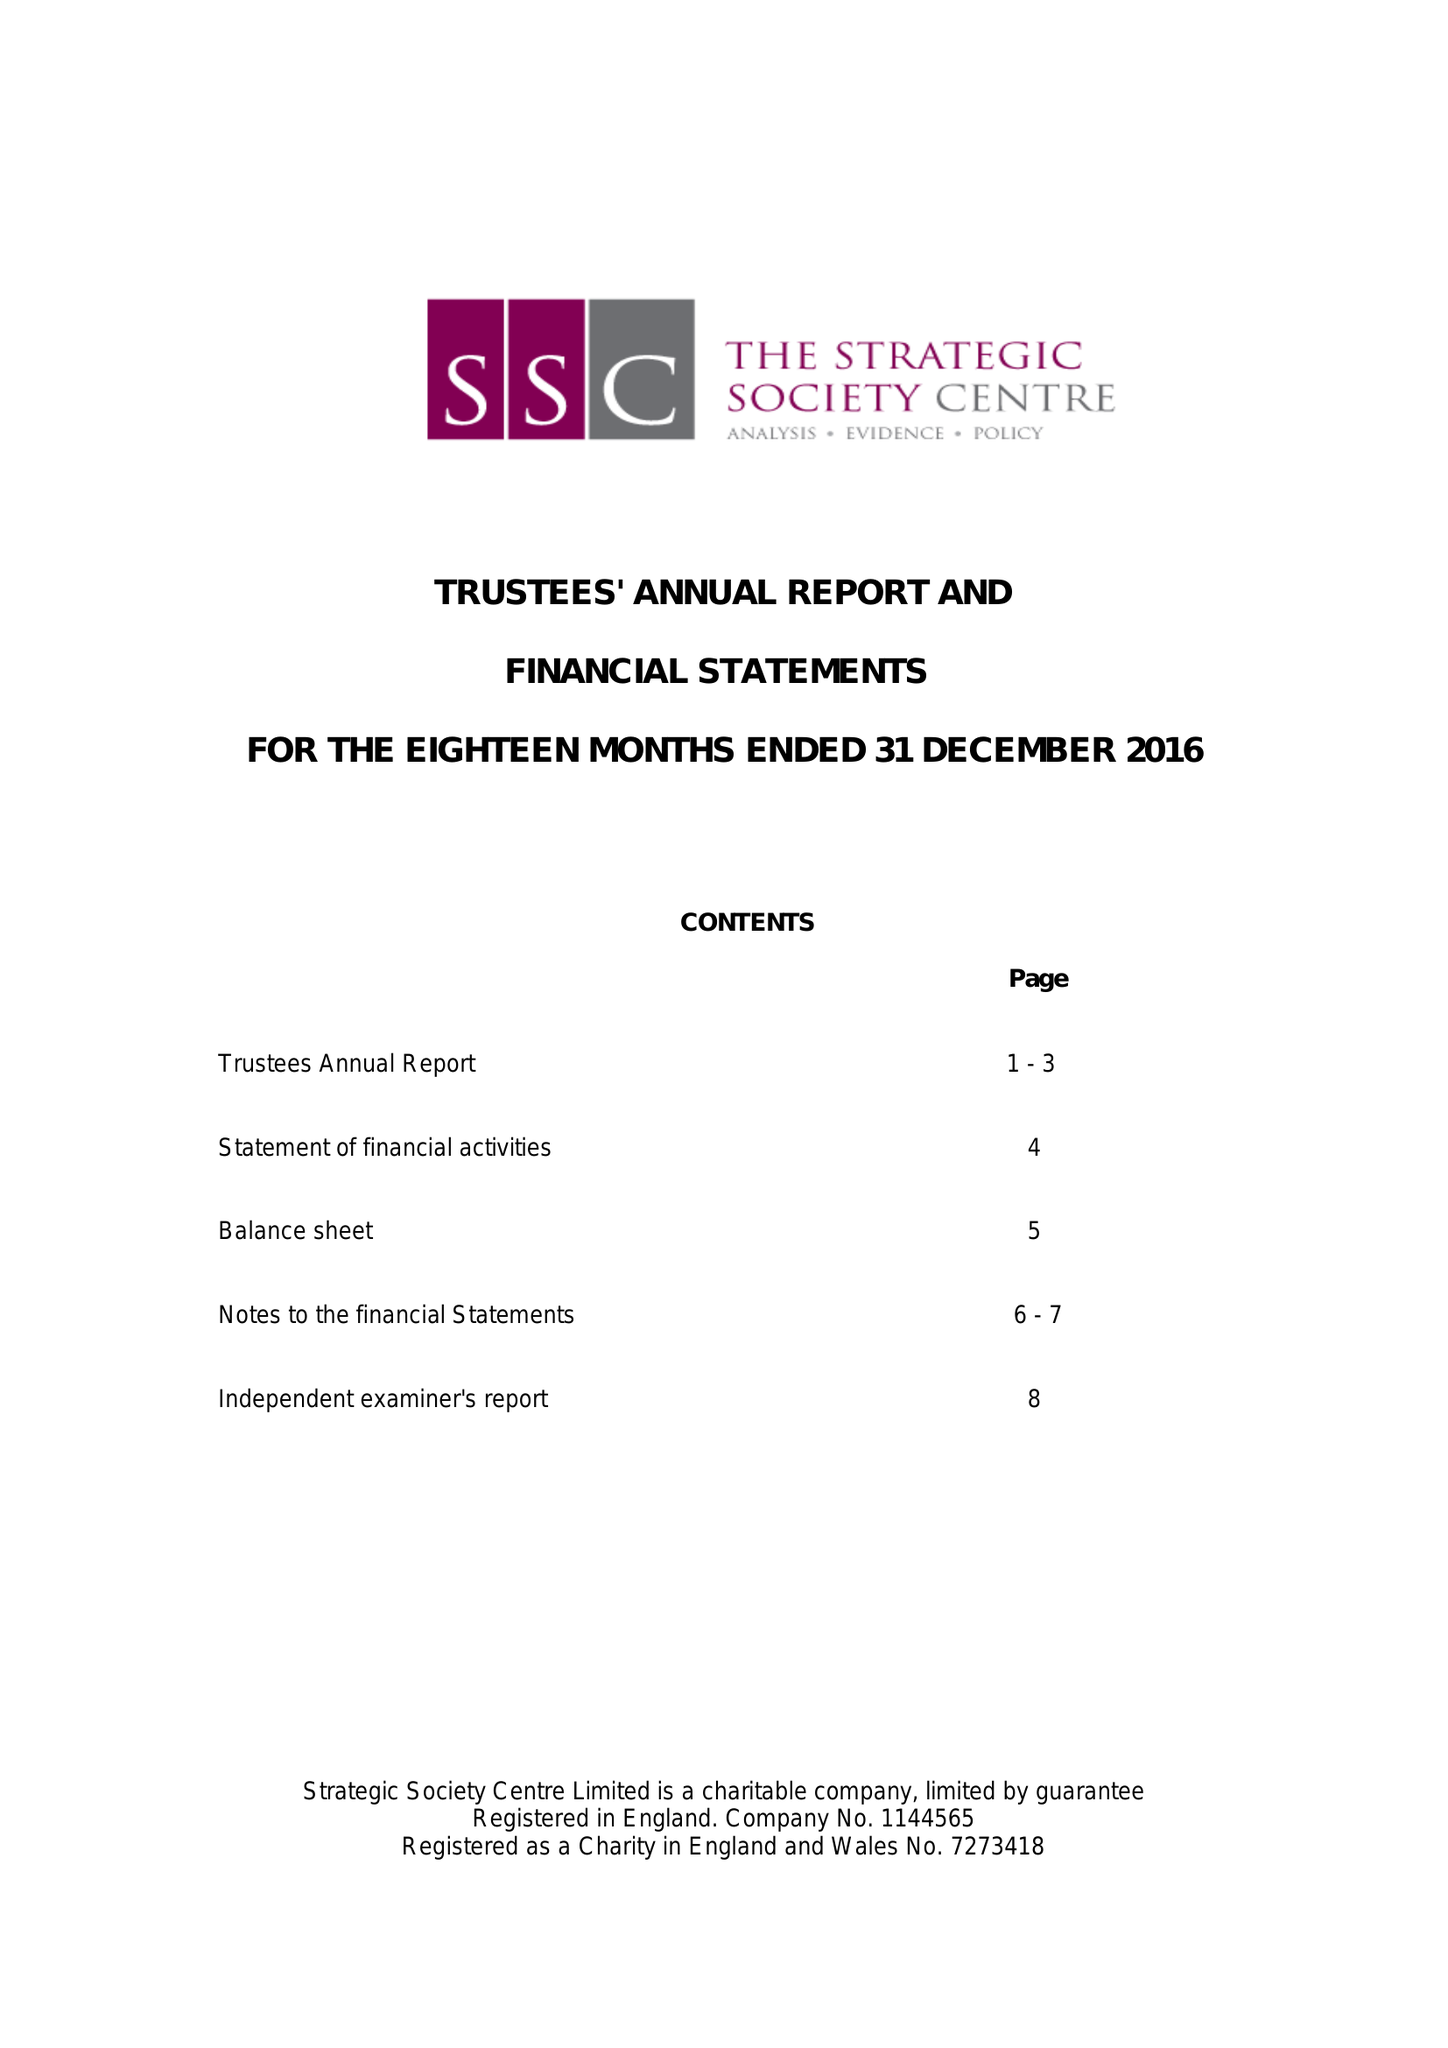What is the value for the address__street_line?
Answer the question using a single word or phrase. 20-22 WENLOCK ROAD 